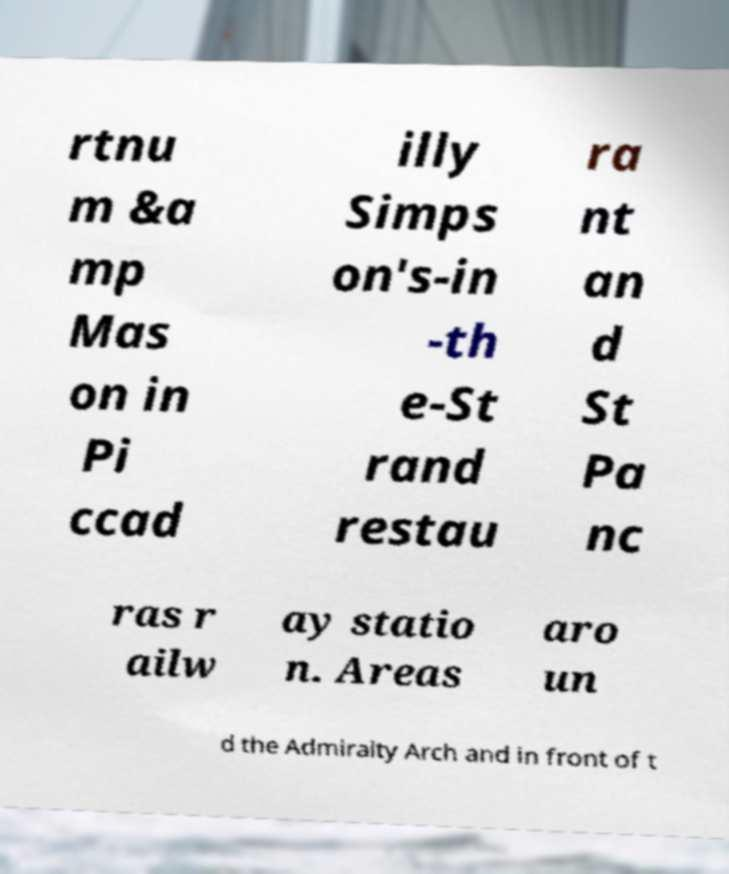I need the written content from this picture converted into text. Can you do that? rtnu m &a mp Mas on in Pi ccad illy Simps on's-in -th e-St rand restau ra nt an d St Pa nc ras r ailw ay statio n. Areas aro un d the Admiralty Arch and in front of t 